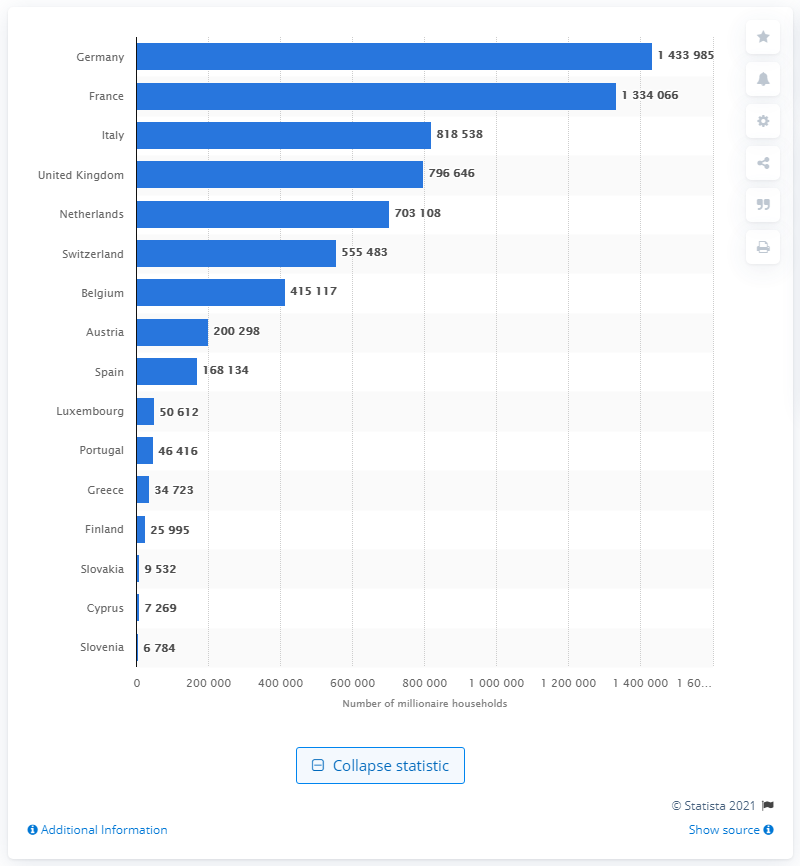List a handful of essential elements in this visual. Germany has the largest number of millionaire households. 